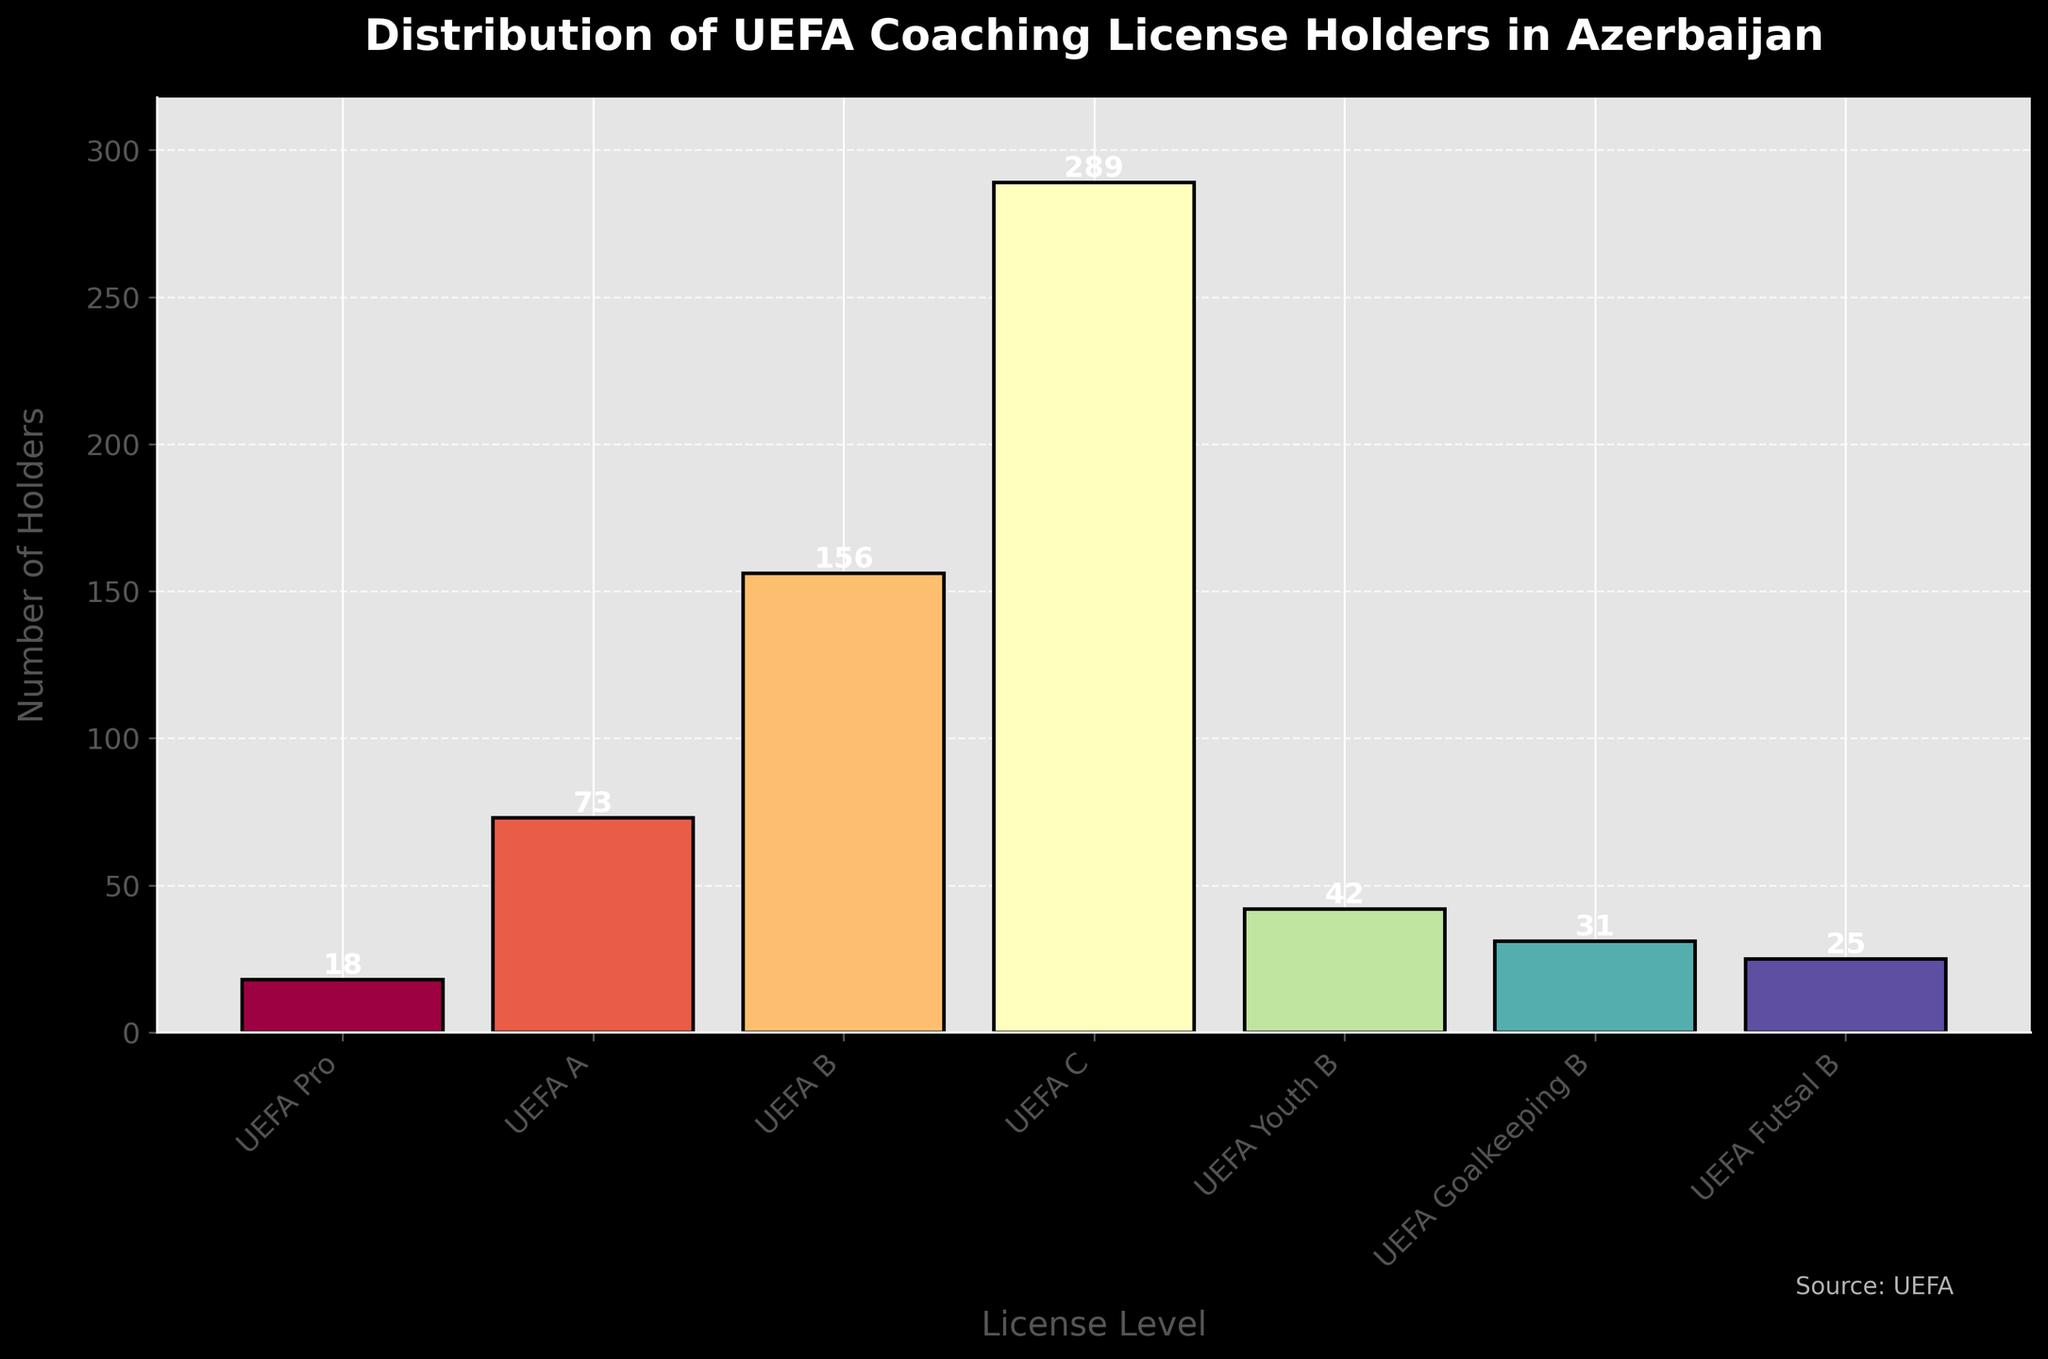What is the license level with the highest number of holders? The tallest bar in the figure represents the license level with the highest number of holders. By looking at the height of the bars, UEFA C has the highest number of holders.
Answer: UEFA C Which license level has the least number of holders? The shortest bar in the figure represents the license level with the least number of holders. By identifying the shortest bar, UEFA Pro has the least number of holders.
Answer: UEFA Pro What is the total number of UEFA coaching license holders in Azerbaijan? To find the total number of holders, sum up the heights of all the bars: 18 (UEFA Pro) + 73 (UEFA A) + 156 (UEFA B) + 289 (UEFA C) + 42 (UEFA Youth B) + 31 (UEFA Goalkeeping B) + 25 (UEFA Futsal B) = 634 holders.
Answer: 634 How many more holders does UEFA C have compared to UEFA B? Subtract the number of UEFA B holders from the number of UEFA C holders: 289 (UEFA C) - 156 (UEFA B) = 133 more holders.
Answer: 133 What is the average number of holders for all license levels? Calculate the sum of all holders and then divide by the number of license levels: (18 + 73 + 156 + 289 + 42 + 31 + 25) / 7 ≈ 90.57 holders on average.
Answer: 90.57 Which license levels have more than 50 holders? Identify and list the bars where the height is greater than 50: UEFA A (73), UEFA B (156), and UEFA C (289).
Answer: UEFA A, UEFA B, UEFA C What is the difference between the number of UEFA Youth B and UEFA Goalkeeping B holders? Find the difference by subtracting the smaller number from the larger: 42 (UEFA Youth B) - 31 (UEFA Goalkeeping B) = 11.
Answer: 11 Which license level is represented with the second tallest bar? The second tallest bar represents the license level with the second highest number of holders. By visually comparing, UEFA B is the second tallest bar after UEFA C.
Answer: UEFA B What percentage of the total holders does the UEFA A license represent? Divide the number of UEFA A holders by the total number of holders and multiply by 100 to get the percentage: (73 / 634) * 100 ≈ 11.52%.
Answer: 11.52 Are there more holders with UEFA B licenses or the combined holders of UEFA Youth B and UEFA Goalkeeping B licenses? Combine the holders of UEFA Youth B and UEFA Goalkeeping B, then compare with UEFA B: 42 (UEFA Youth B) + 31 (UEFA Goalkeeping B) = 73, which is less than 156 (UEFA B).
Answer: UEFA B 